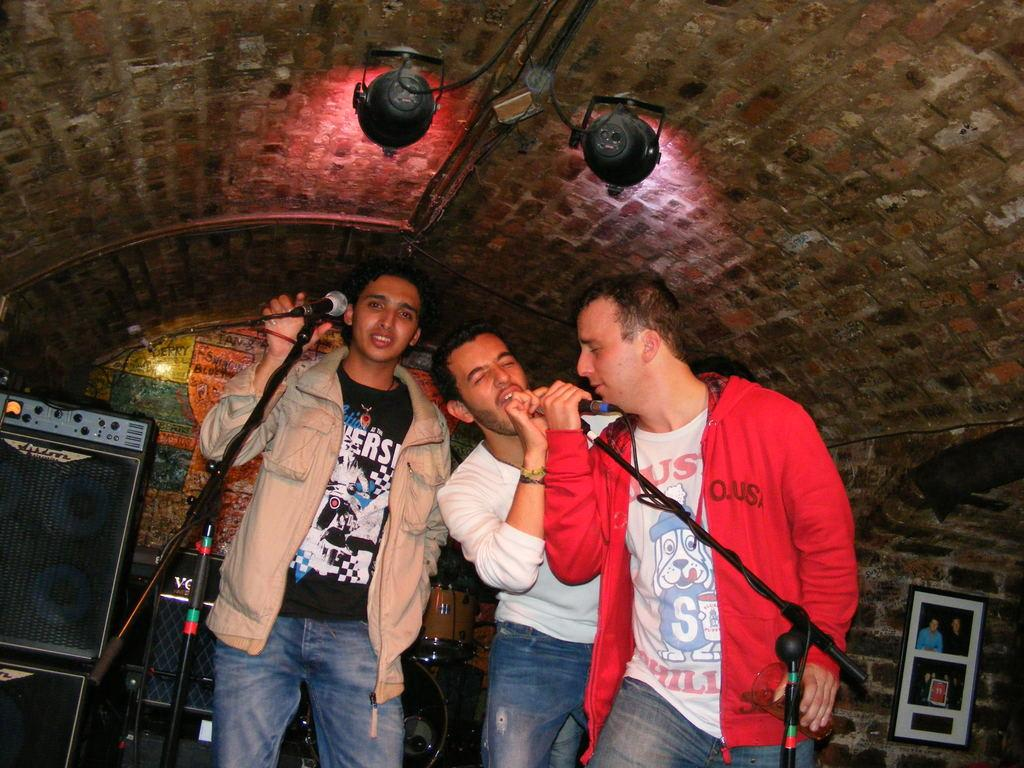How many people are in the image? There are three persons standing in the image. What are the persons holding in the image? The persons are holding microphones. What can be seen in the background of the image? There is a speaker box, drums, photo frames, and lights in the background of the image. What type of throne is visible in the image? There is no throne present in the image. What happens to the lights when they burst in the image? There is no indication in the image that the lights burst or that there is any such event occurring. 